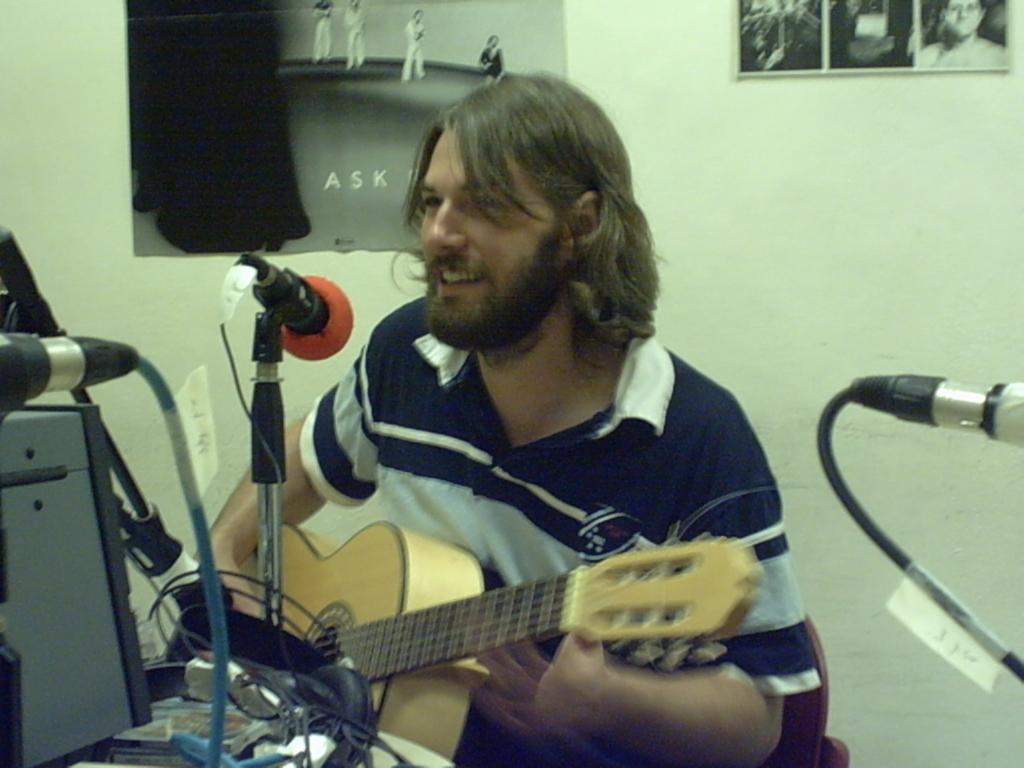In one or two sentences, can you explain what this image depicts? A man is sitting on chair holds a guitar. In-front of this man there is a mic and holder. On a wall there are different type of pictures. This are cables. 